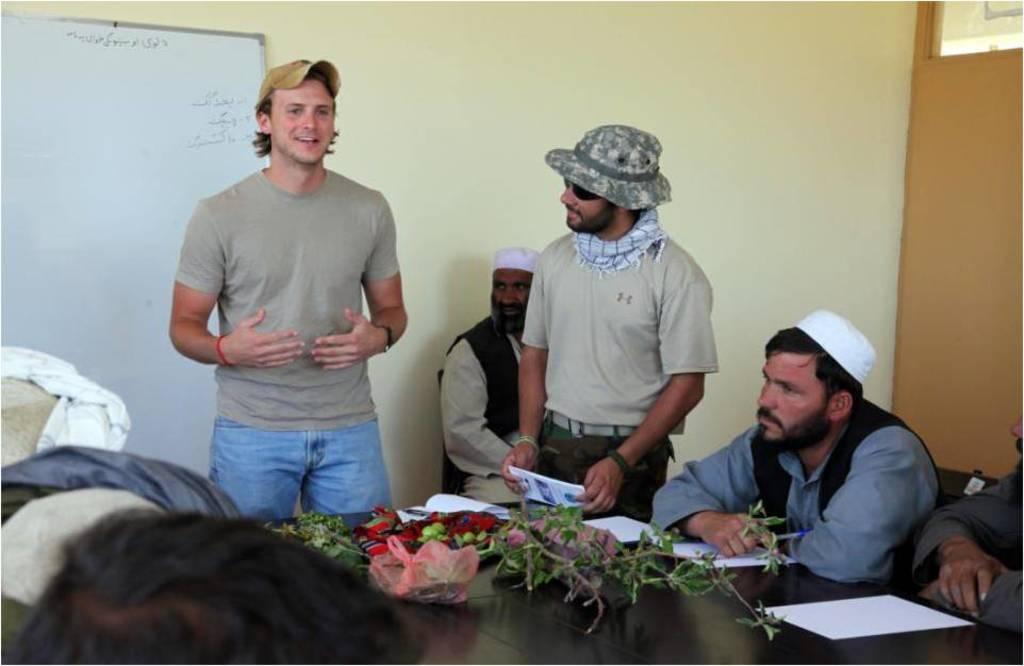Describe this image in one or two sentences. In this picture, we can see a few people sitting and a few are standing, we can see table, and we can see some objects on the table like plants, paper, we can see the wall with board, door. 